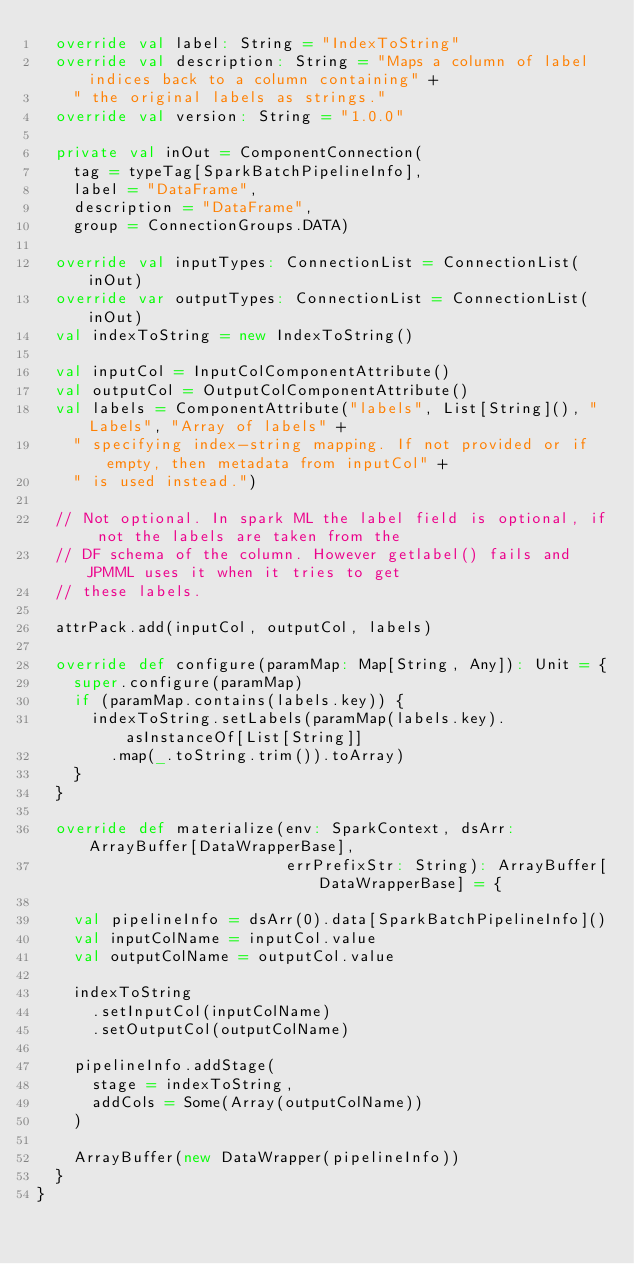<code> <loc_0><loc_0><loc_500><loc_500><_Scala_>  override val label: String = "IndexToString"
  override val description: String = "Maps a column of label indices back to a column containing" +
    " the original labels as strings."
  override val version: String = "1.0.0"

  private val inOut = ComponentConnection(
    tag = typeTag[SparkBatchPipelineInfo],
    label = "DataFrame",
    description = "DataFrame",
    group = ConnectionGroups.DATA)

  override val inputTypes: ConnectionList = ConnectionList(inOut)
  override var outputTypes: ConnectionList = ConnectionList(inOut)
  val indexToString = new IndexToString()

  val inputCol = InputColComponentAttribute()
  val outputCol = OutputColComponentAttribute()
  val labels = ComponentAttribute("labels", List[String](), "Labels", "Array of labels" +
    " specifying index-string mapping. If not provided or if empty, then metadata from inputCol" +
    " is used instead.")

  // Not optional. In spark ML the label field is optional, if not the labels are taken from the
  // DF schema of the column. However getlabel() fails and JPMML uses it when it tries to get
  // these labels.

  attrPack.add(inputCol, outputCol, labels)

  override def configure(paramMap: Map[String, Any]): Unit = {
    super.configure(paramMap)
    if (paramMap.contains(labels.key)) {
      indexToString.setLabels(paramMap(labels.key).asInstanceOf[List[String]]
        .map(_.toString.trim()).toArray)
    }
  }

  override def materialize(env: SparkContext, dsArr: ArrayBuffer[DataWrapperBase],
                           errPrefixStr: String): ArrayBuffer[DataWrapperBase] = {

    val pipelineInfo = dsArr(0).data[SparkBatchPipelineInfo]()
    val inputColName = inputCol.value
    val outputColName = outputCol.value

    indexToString
      .setInputCol(inputColName)
      .setOutputCol(outputColName)

    pipelineInfo.addStage(
      stage = indexToString,
      addCols = Some(Array(outputColName))
    )

    ArrayBuffer(new DataWrapper(pipelineInfo))
  }
}
</code> 